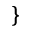Convert formula to latex. <formula><loc_0><loc_0><loc_500><loc_500>\}</formula> 